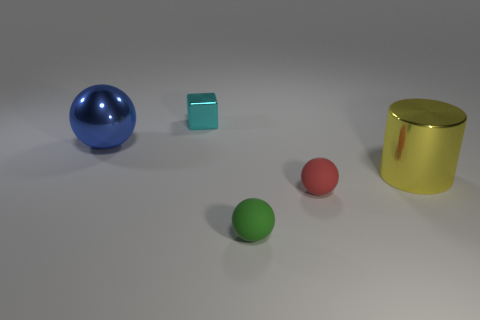Add 2 big gray metal cubes. How many objects exist? 7 Subtract all balls. How many objects are left? 2 Subtract all spheres. Subtract all tiny metal things. How many objects are left? 1 Add 2 spheres. How many spheres are left? 5 Add 2 tiny yellow matte blocks. How many tiny yellow matte blocks exist? 2 Subtract 0 brown cubes. How many objects are left? 5 